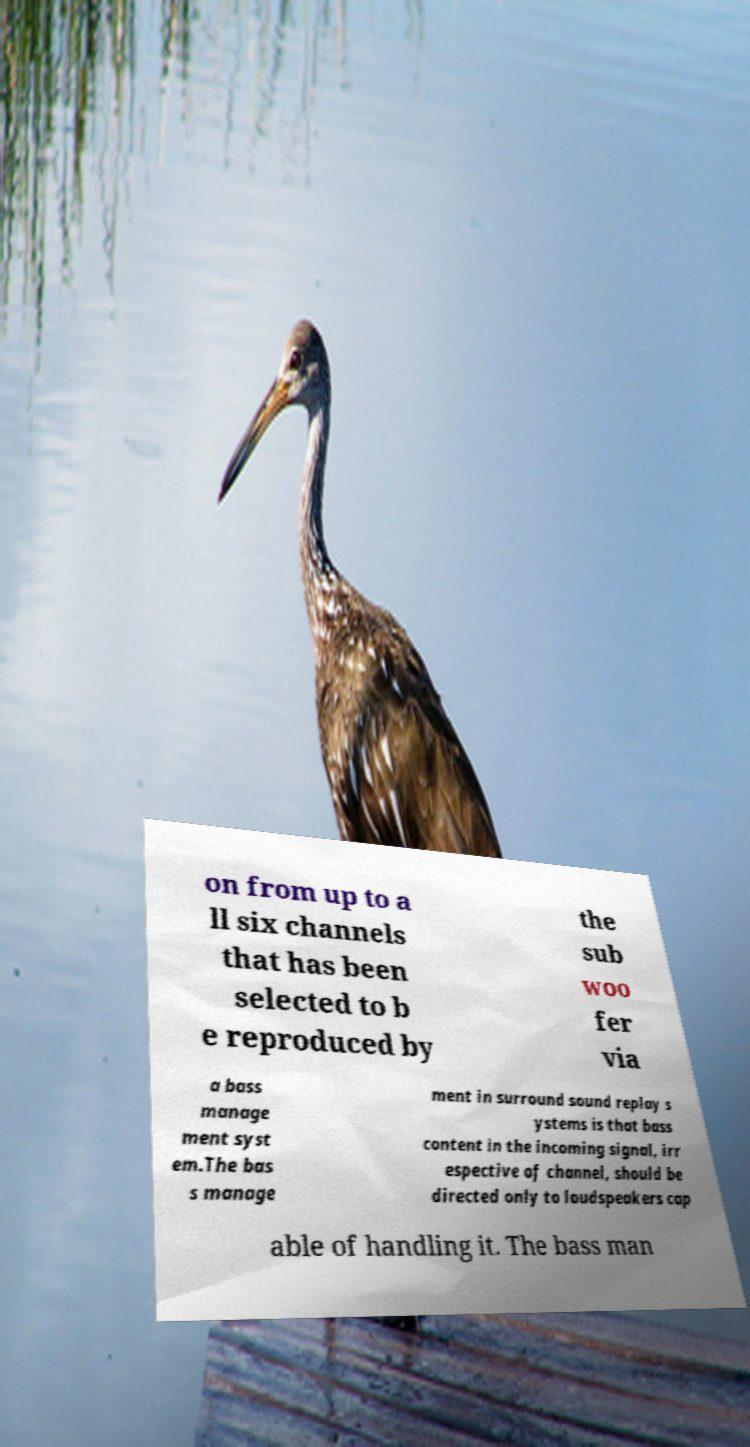What messages or text are displayed in this image? I need them in a readable, typed format. on from up to a ll six channels that has been selected to b e reproduced by the sub woo fer via a bass manage ment syst em.The bas s manage ment in surround sound replay s ystems is that bass content in the incoming signal, irr espective of channel, should be directed only to loudspeakers cap able of handling it. The bass man 